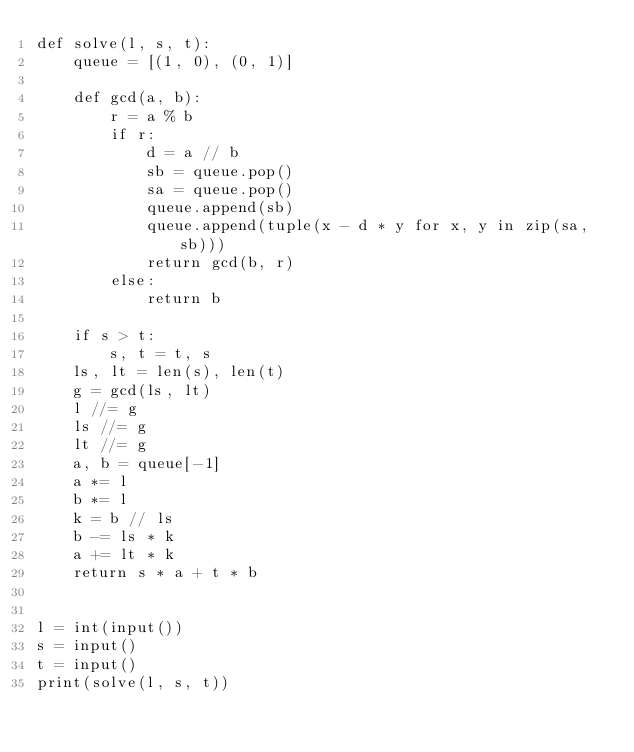<code> <loc_0><loc_0><loc_500><loc_500><_Python_>def solve(l, s, t):
    queue = [(1, 0), (0, 1)]

    def gcd(a, b):
        r = a % b
        if r:
            d = a // b
            sb = queue.pop()
            sa = queue.pop()
            queue.append(sb)
            queue.append(tuple(x - d * y for x, y in zip(sa, sb)))
            return gcd(b, r)
        else:
            return b

    if s > t:
        s, t = t, s
    ls, lt = len(s), len(t)
    g = gcd(ls, lt)
    l //= g
    ls //= g
    lt //= g
    a, b = queue[-1]
    a *= l
    b *= l
    k = b // ls
    b -= ls * k
    a += lt * k
    return s * a + t * b


l = int(input())
s = input()
t = input()
print(solve(l, s, t))
</code> 